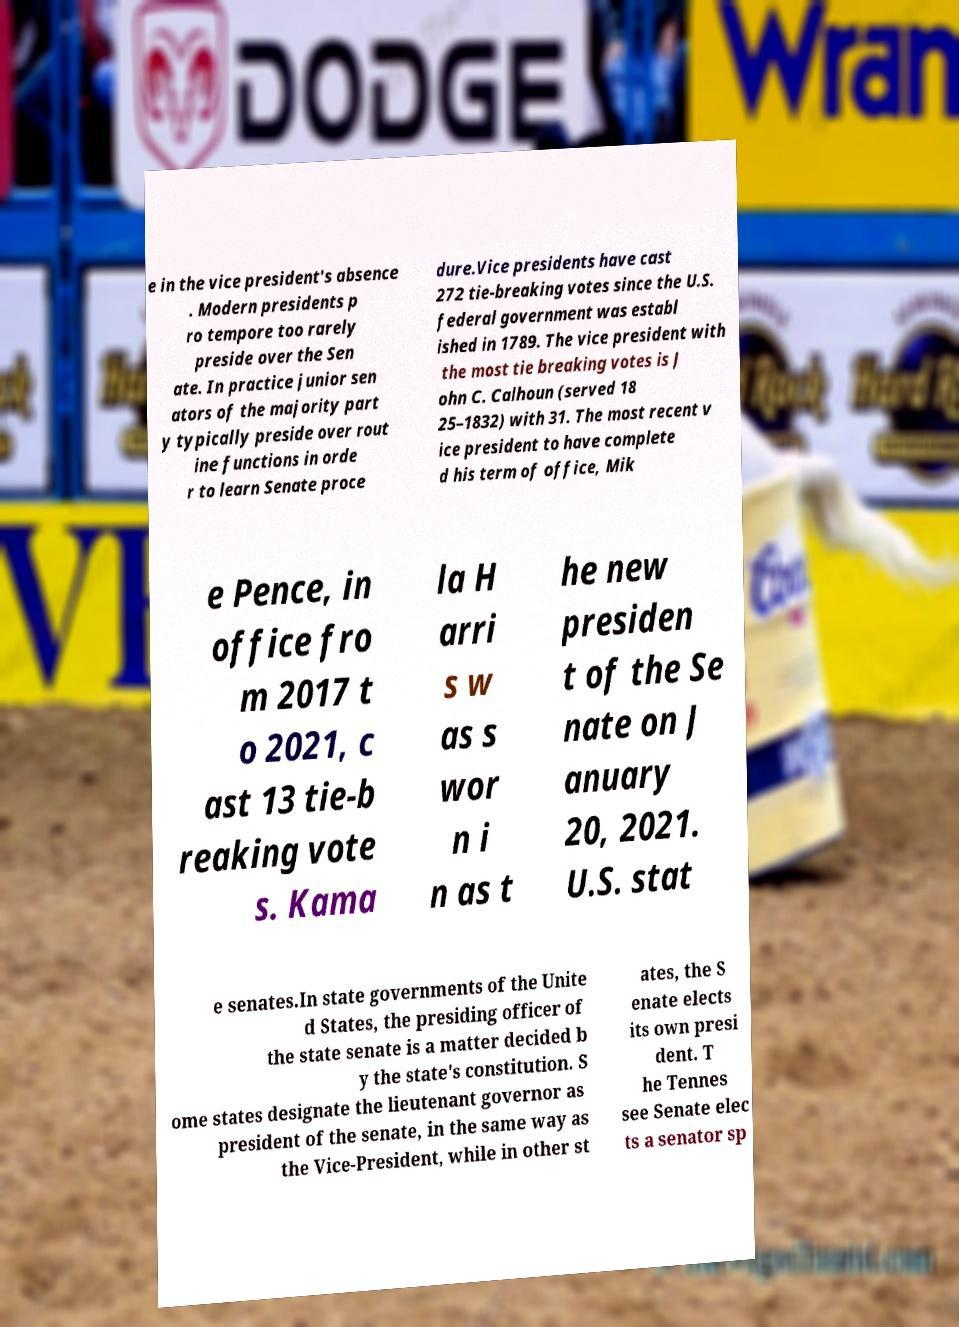Could you assist in decoding the text presented in this image and type it out clearly? e in the vice president's absence . Modern presidents p ro tempore too rarely preside over the Sen ate. In practice junior sen ators of the majority part y typically preside over rout ine functions in orde r to learn Senate proce dure.Vice presidents have cast 272 tie-breaking votes since the U.S. federal government was establ ished in 1789. The vice president with the most tie breaking votes is J ohn C. Calhoun (served 18 25–1832) with 31. The most recent v ice president to have complete d his term of office, Mik e Pence, in office fro m 2017 t o 2021, c ast 13 tie-b reaking vote s. Kama la H arri s w as s wor n i n as t he new presiden t of the Se nate on J anuary 20, 2021. U.S. stat e senates.In state governments of the Unite d States, the presiding officer of the state senate is a matter decided b y the state's constitution. S ome states designate the lieutenant governor as president of the senate, in the same way as the Vice-President, while in other st ates, the S enate elects its own presi dent. T he Tennes see Senate elec ts a senator sp 